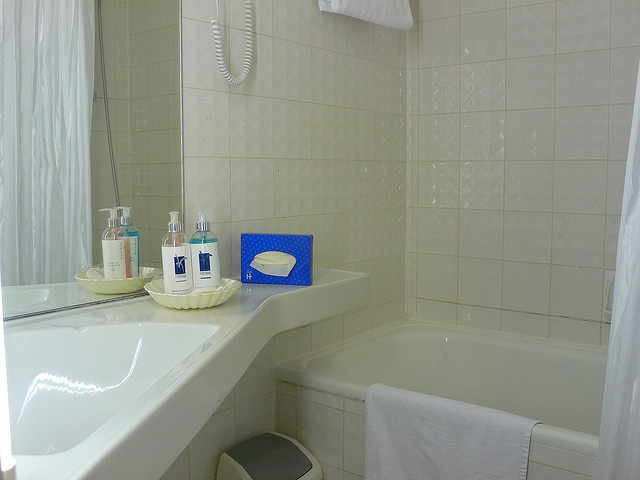Describe the objects in this image and their specific colors. I can see sink in lightgray tones, bottle in lightgray, darkgray, and gray tones, bowl in lightgray, tan, and beige tones, bottle in lightgray, darkgray, and navy tones, and bottle in lightgray, darkgray, and gray tones in this image. 